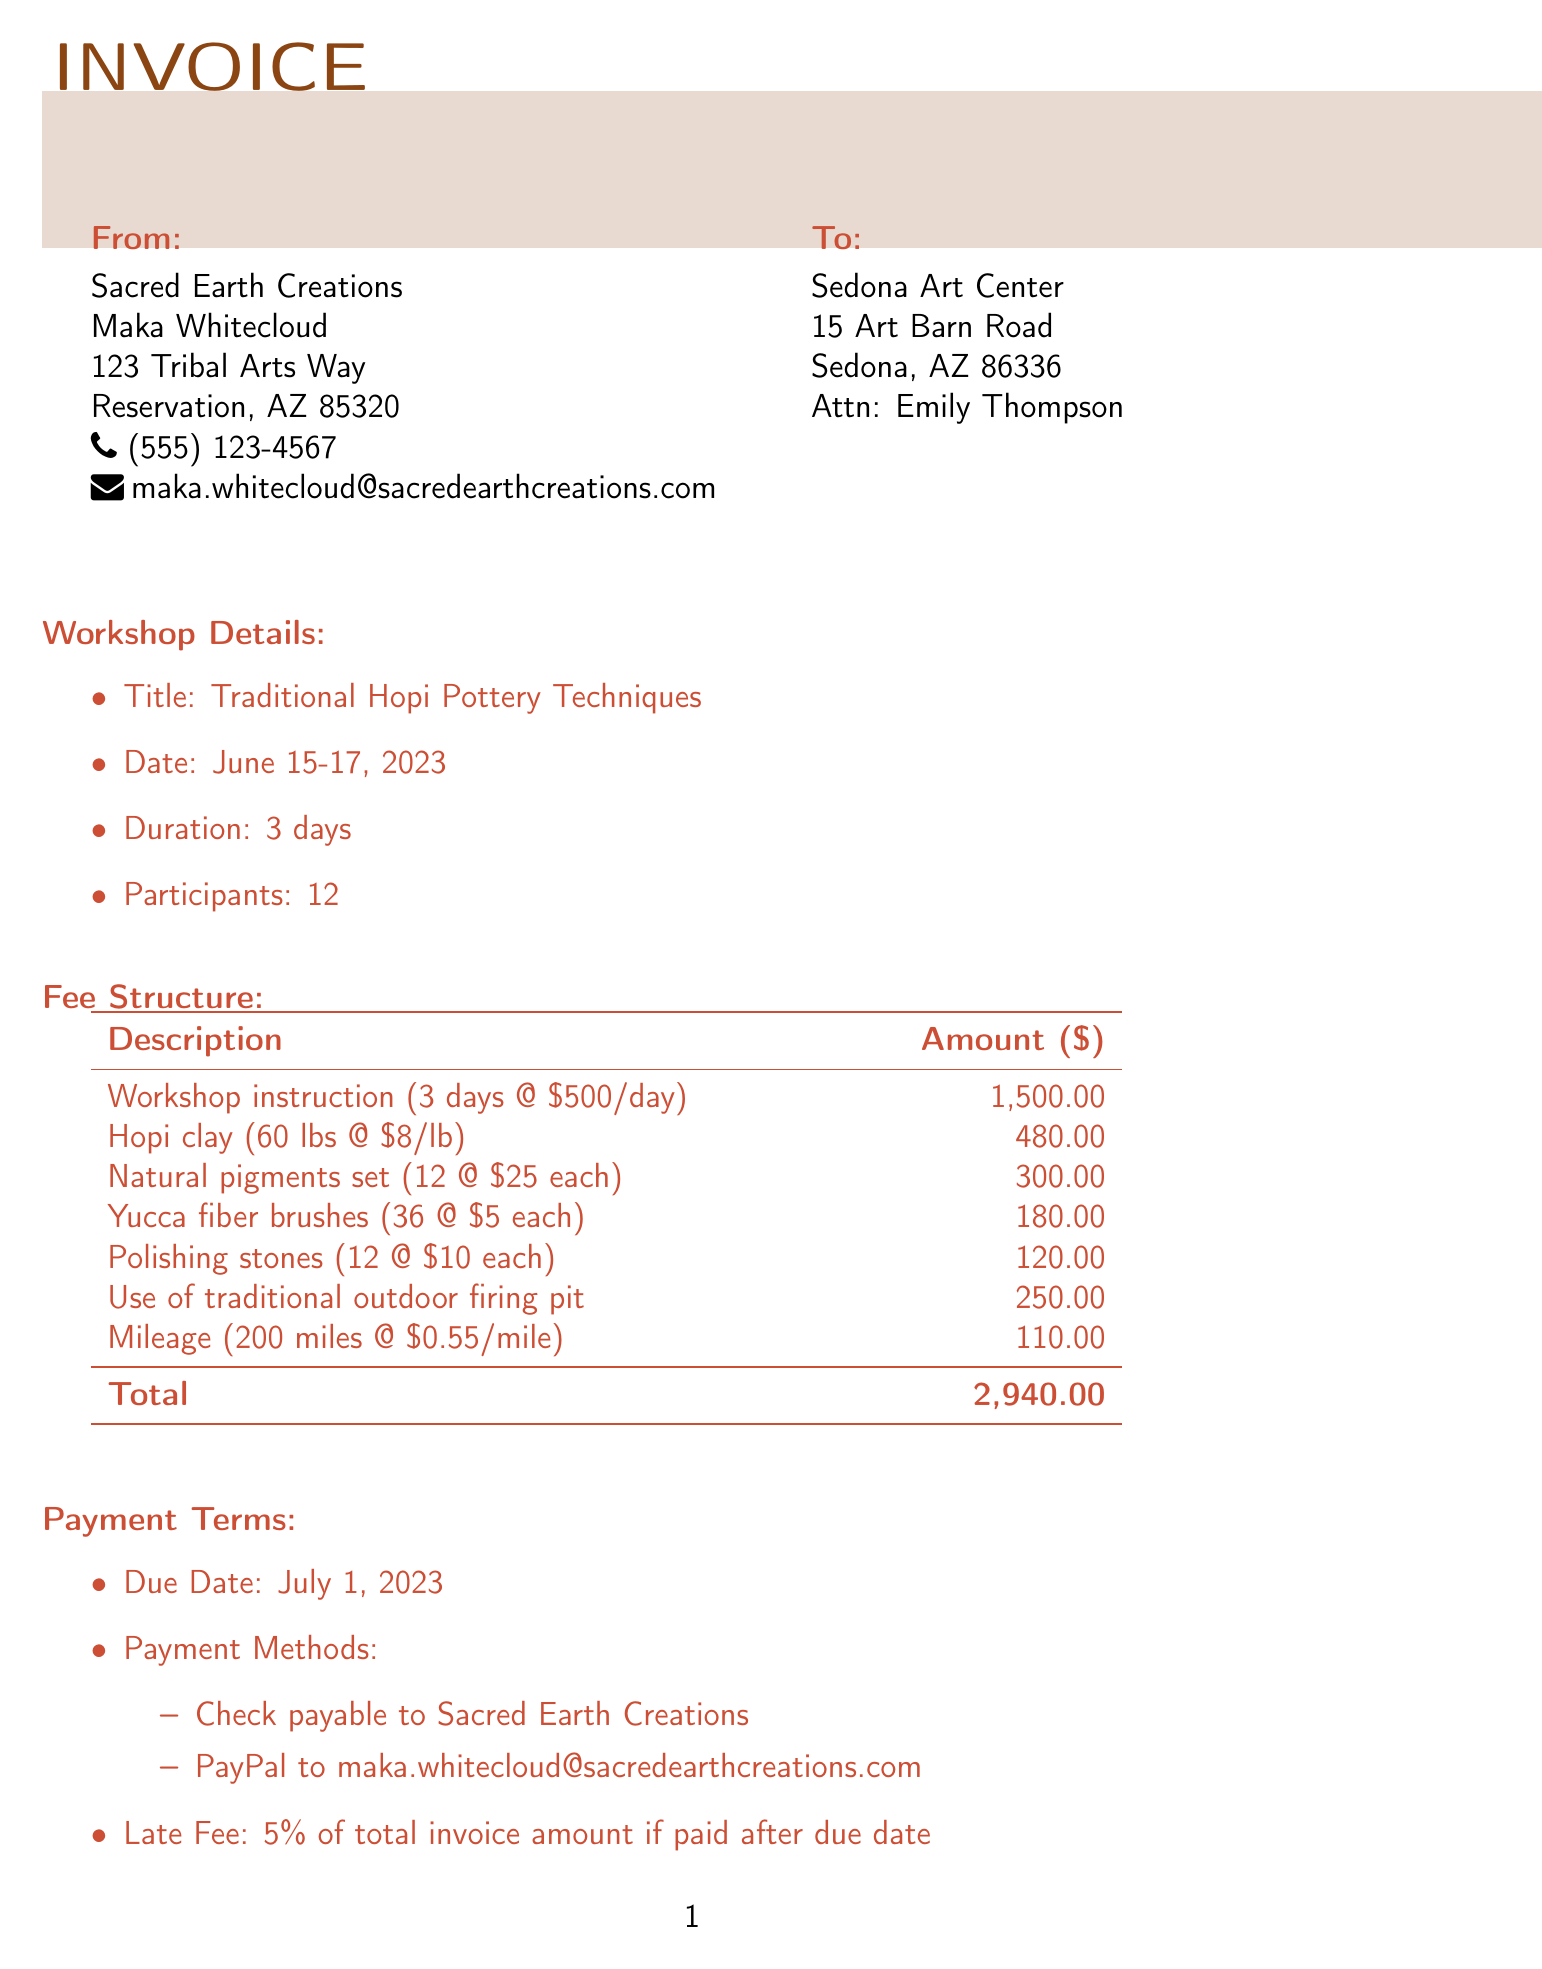What is the artist's name? The artist's name is listed at the top of the invoice under the header section.
Answer: Maka Whitecloud What is the total amount due? The total amount due is found in the fee structure section of the invoice.
Answer: 2,940.00 On what date is the workshop taking place? The workshop date is specified in the workshop details section of the invoice.
Answer: June 15-17, 2023 How many participants were in the workshop? The number of participants is mentioned in the workshop details section.
Answer: 12 What is the facility fee amount? The facility fee is outlined in the fee structure as a separate line item.
Answer: 250.00 What is the late fee percentage? The late fee percentage is mentioned under the payment terms section.
Answer: 5% What materials were used in the workshop? The materials are detailed in the fee structure section under materials fee.
Answer: Hopi clay, Natural pigments set, Yucca fiber brushes, Polishing stones Who is the contact person for the client? The contact person's name is provided in the client information section of the invoice.
Answer: Emily Thompson What payment methods are accepted? The payment methods are listed in the payment terms section of the invoice.
Answer: Check, PayPal 